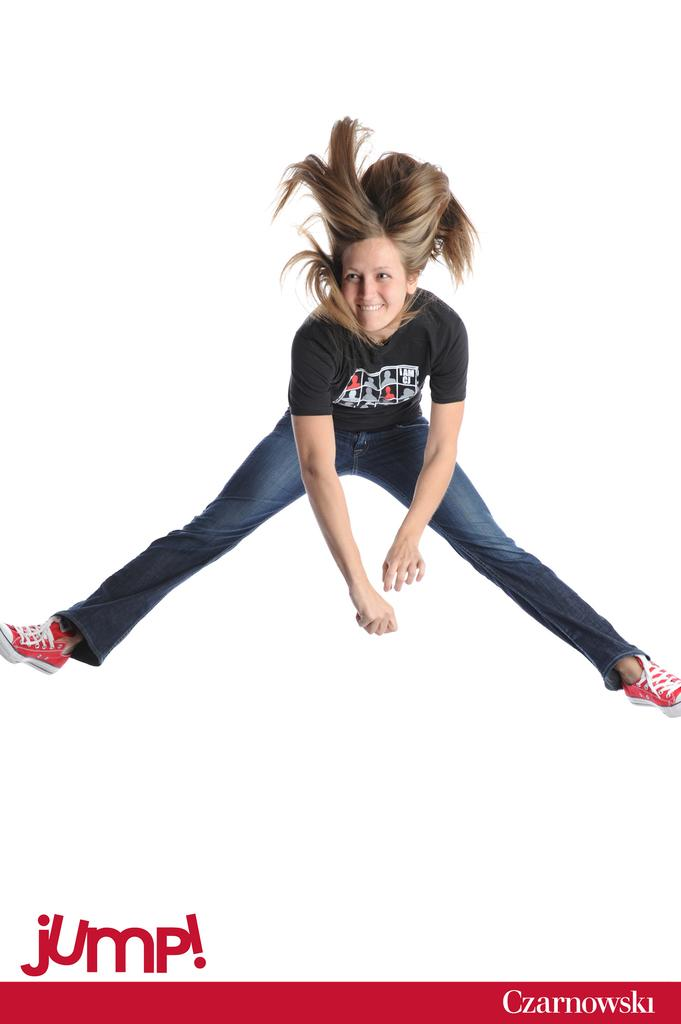Who is the main subject in the image? There is a lady in the image. What is the lady doing in the image? The lady is jumping. What expression does the lady have in the image? The lady is smiling. What type of design is on the lady's shirt in the image? There is no information about the lady's shirt or any design on it in the provided facts. --- Facts: 1. There is a car in the image. 2. The car is red. 3. The car has four wheels. 4. The car has a license plate. Absurd Topics: bird, ocean, mountain Conversation: What is the main subject in the image? There is a car in the image. What color is the car in the image? The car is red. How many wheels does the car have in the image? The car has four wheels. Does the car have any identifying features in the image? Yes, the car has a license plate. Reasoning: Let's think step by step in order to produce the conversation. We start by identifying the main subject in the image, which is the car. Then, we describe its color and the number of wheels it has. Finally, we mention the presence of a license plate, which is an identifying feature. Each question is designed to elicit a specific detail about the image that is known from the provided facts. Absurd Question/Answer: Can you see any birds flying over the ocean in the image? There is no mention of birds, the ocean, or any mountains in the provided facts, so we cannot answer this question based on the image. 